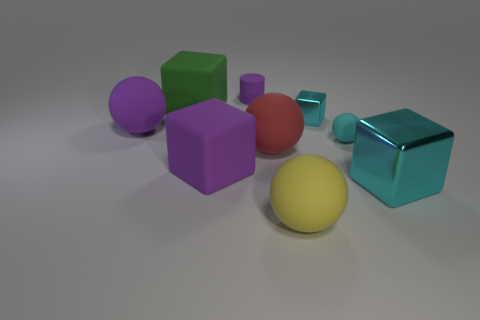Do the green thing and the yellow thing have the same size?
Your answer should be very brief. Yes. Are there an equal number of purple blocks that are to the left of the big purple sphere and small objects in front of the green matte thing?
Offer a terse response. No. What is the shape of the object that is behind the big green matte object?
Your response must be concise. Cylinder. There is a purple rubber thing that is the same size as the cyan sphere; what shape is it?
Keep it short and to the point. Cylinder. What is the color of the metallic block that is behind the tiny cyan object that is to the right of the cyan metallic thing that is behind the purple ball?
Your response must be concise. Cyan. Is the red object the same shape as the large yellow rubber object?
Keep it short and to the point. Yes. Are there the same number of tiny purple matte cylinders to the right of the rubber cylinder and large green metallic cubes?
Give a very brief answer. Yes. What number of other objects are there of the same material as the big red object?
Provide a short and direct response. 6. Do the sphere to the right of the yellow matte ball and the cyan metallic cube that is in front of the red rubber thing have the same size?
Ensure brevity in your answer.  No. How many things are tiny rubber things that are right of the yellow ball or big things left of the yellow rubber ball?
Offer a very short reply. 5. 